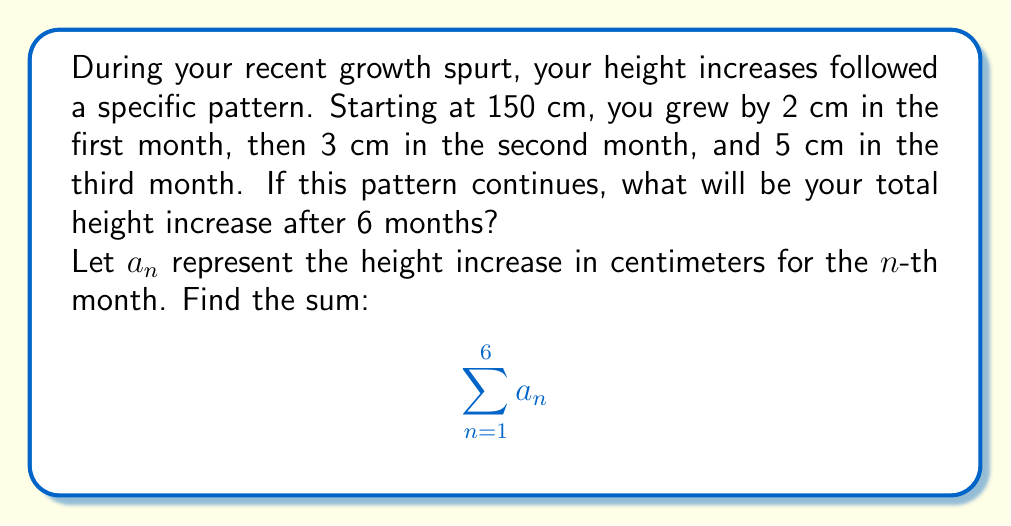Provide a solution to this math problem. Let's approach this step-by-step:

1) First, we need to identify the pattern in the sequence:
   $a_1 = 2$, $a_2 = 3$, $a_3 = 5$

2) We can see that each term is the sum of the two preceding terms:
   $a_3 = a_2 + a_1 = 3 + 2 = 5$

3) This is the Fibonacci sequence. We can continue it:
   $a_4 = a_3 + a_2 = 5 + 3 = 8$
   $a_5 = a_4 + a_3 = 8 + 5 = 13$
   $a_6 = a_5 + a_4 = 13 + 8 = 21$

4) Now we have all six terms: 2, 3, 5, 8, 13, 21

5) To find the total height increase, we sum these terms:

   $$\sum_{n=1}^6 a_n = 2 + 3 + 5 + 8 + 13 + 21 = 52$$

Therefore, the total height increase after 6 months will be 52 cm.
Answer: 52 cm 